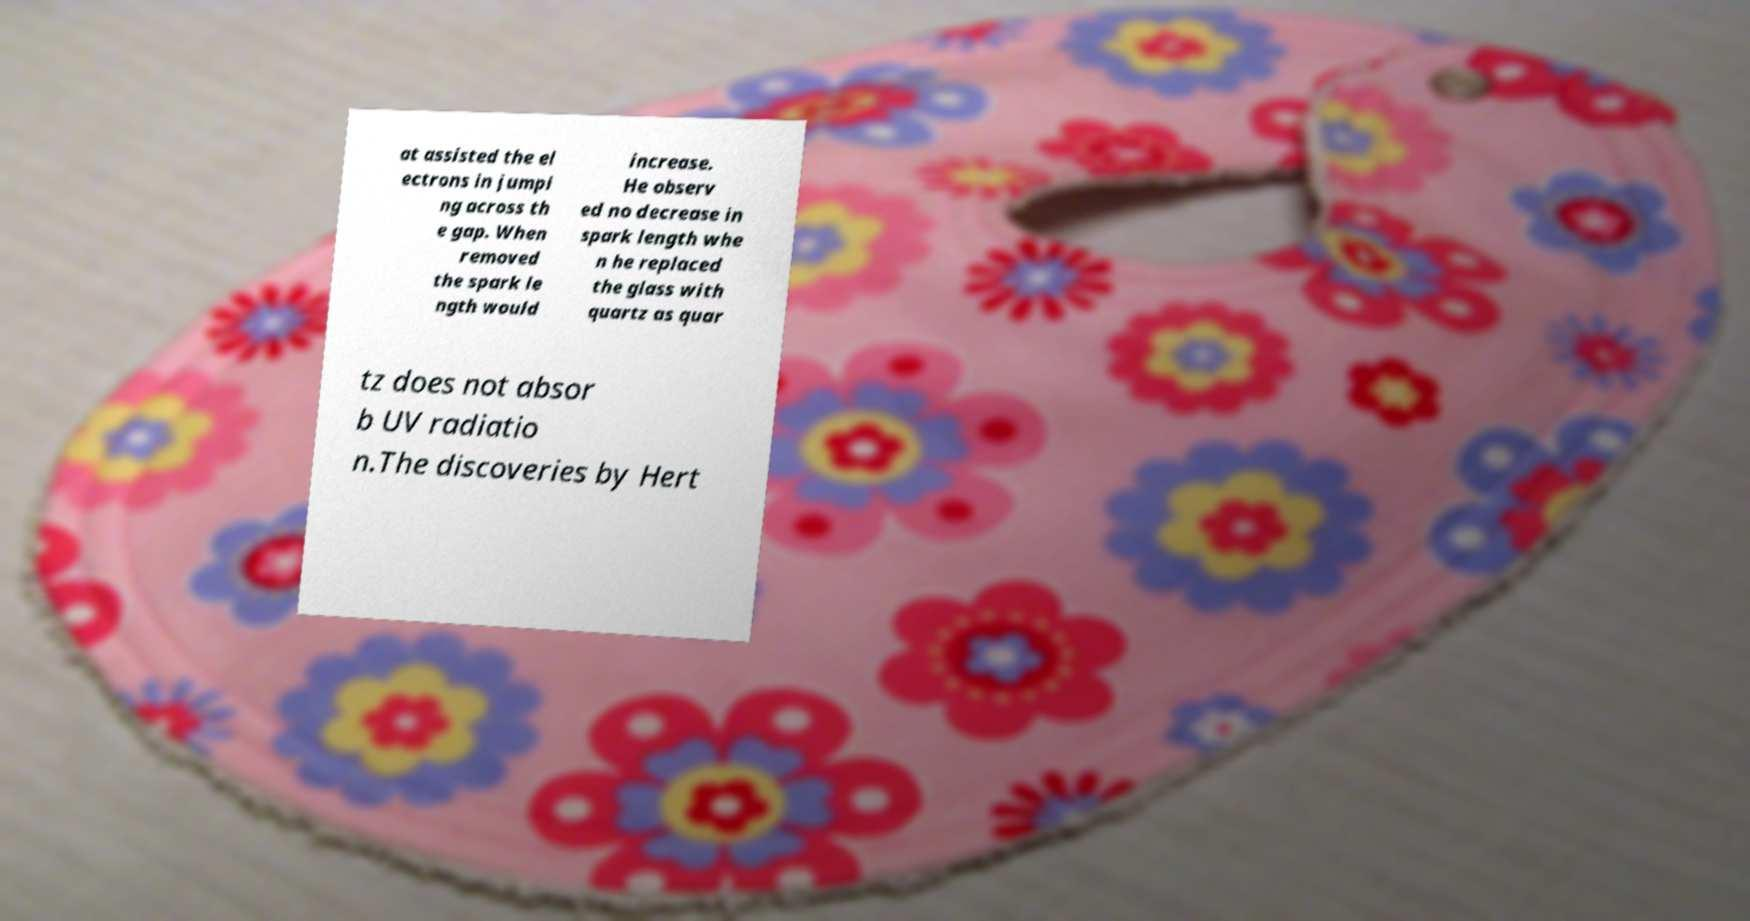Please identify and transcribe the text found in this image. at assisted the el ectrons in jumpi ng across th e gap. When removed the spark le ngth would increase. He observ ed no decrease in spark length whe n he replaced the glass with quartz as quar tz does not absor b UV radiatio n.The discoveries by Hert 